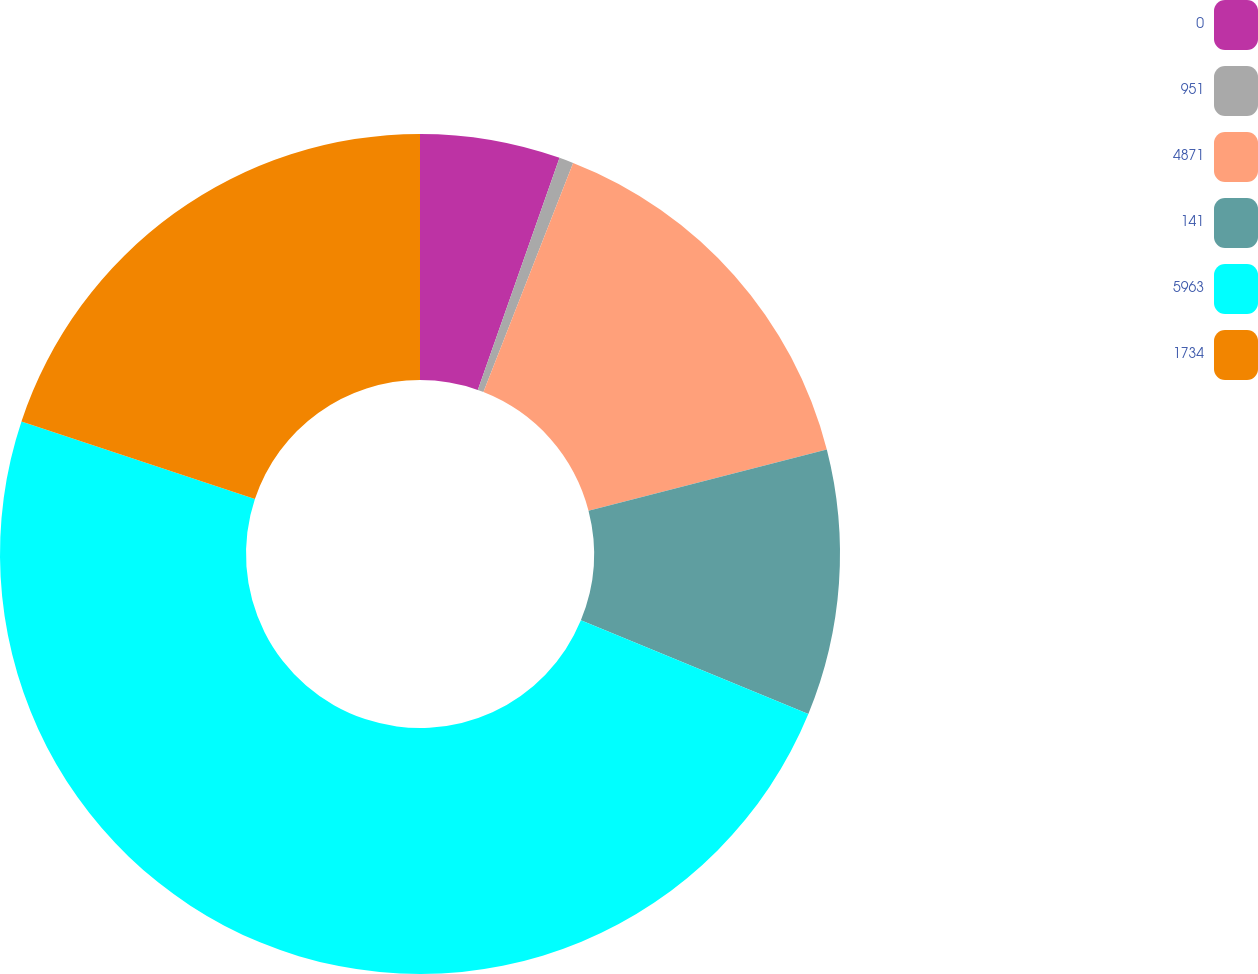Convert chart to OTSL. <chart><loc_0><loc_0><loc_500><loc_500><pie_chart><fcel>0<fcel>951<fcel>4871<fcel>141<fcel>5963<fcel>1734<nl><fcel>5.39%<fcel>0.55%<fcel>15.06%<fcel>10.22%<fcel>48.89%<fcel>19.89%<nl></chart> 